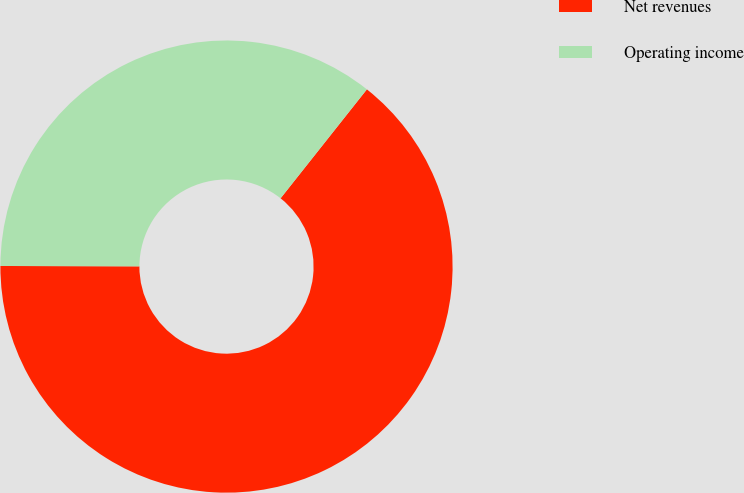Convert chart to OTSL. <chart><loc_0><loc_0><loc_500><loc_500><pie_chart><fcel>Net revenues<fcel>Operating income<nl><fcel>64.38%<fcel>35.62%<nl></chart> 